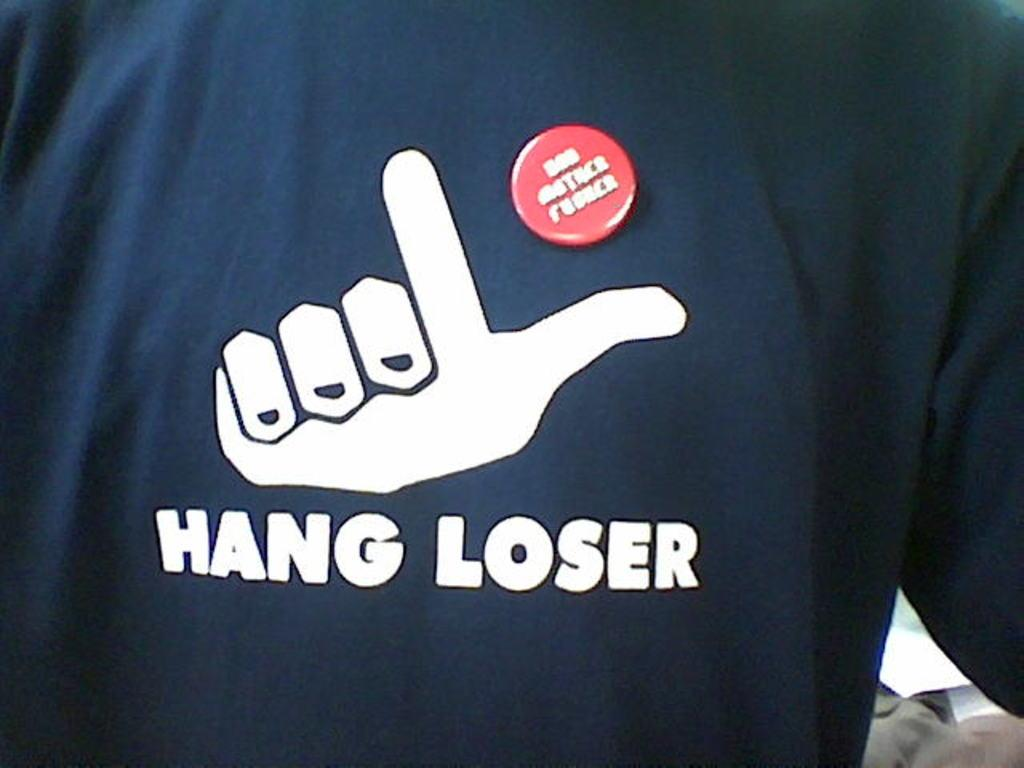<image>
Render a clear and concise summary of the photo. A black t-shirt is adorned with the words "hang loser." 